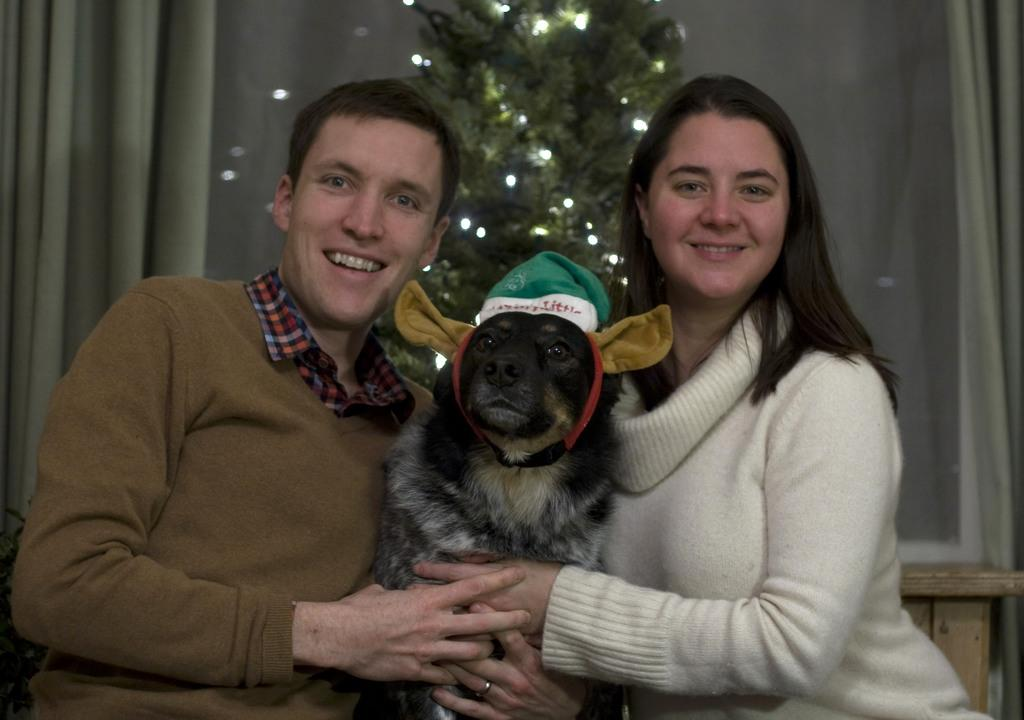How many people are in the image? There are two persons in the image. What are the persons doing in the image? The persons are sitting. What are the persons holding in the image? The persons are holding a dog. What can be seen in the background of the image? There is a curtain in the background of the image. Where is the baseball game taking place in the image? There is no baseball game present in the image. What type of scissors can be seen cutting the curtain in the image? There are no scissors visible in the image, and the curtain is not being cut. 